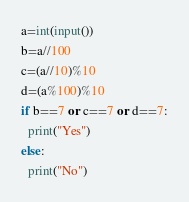Convert code to text. <code><loc_0><loc_0><loc_500><loc_500><_Python_>a=int(input())
b=a//100
c=(a//10)%10
d=(a%100)%10
if b==7 or c==7 or d==7:
  print("Yes")
else:
  print("No")</code> 